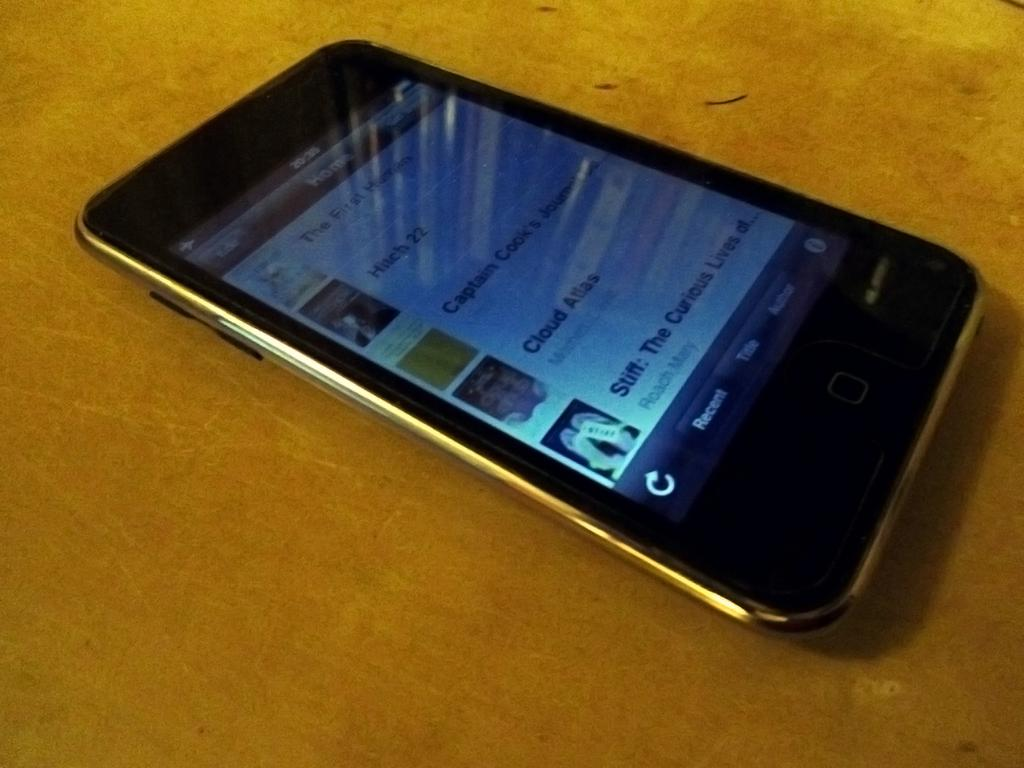Provide a one-sentence caption for the provided image. An Ipod with movie or song icons, including Hitch 22 and  Cloud Atlas is displayed on a table. 